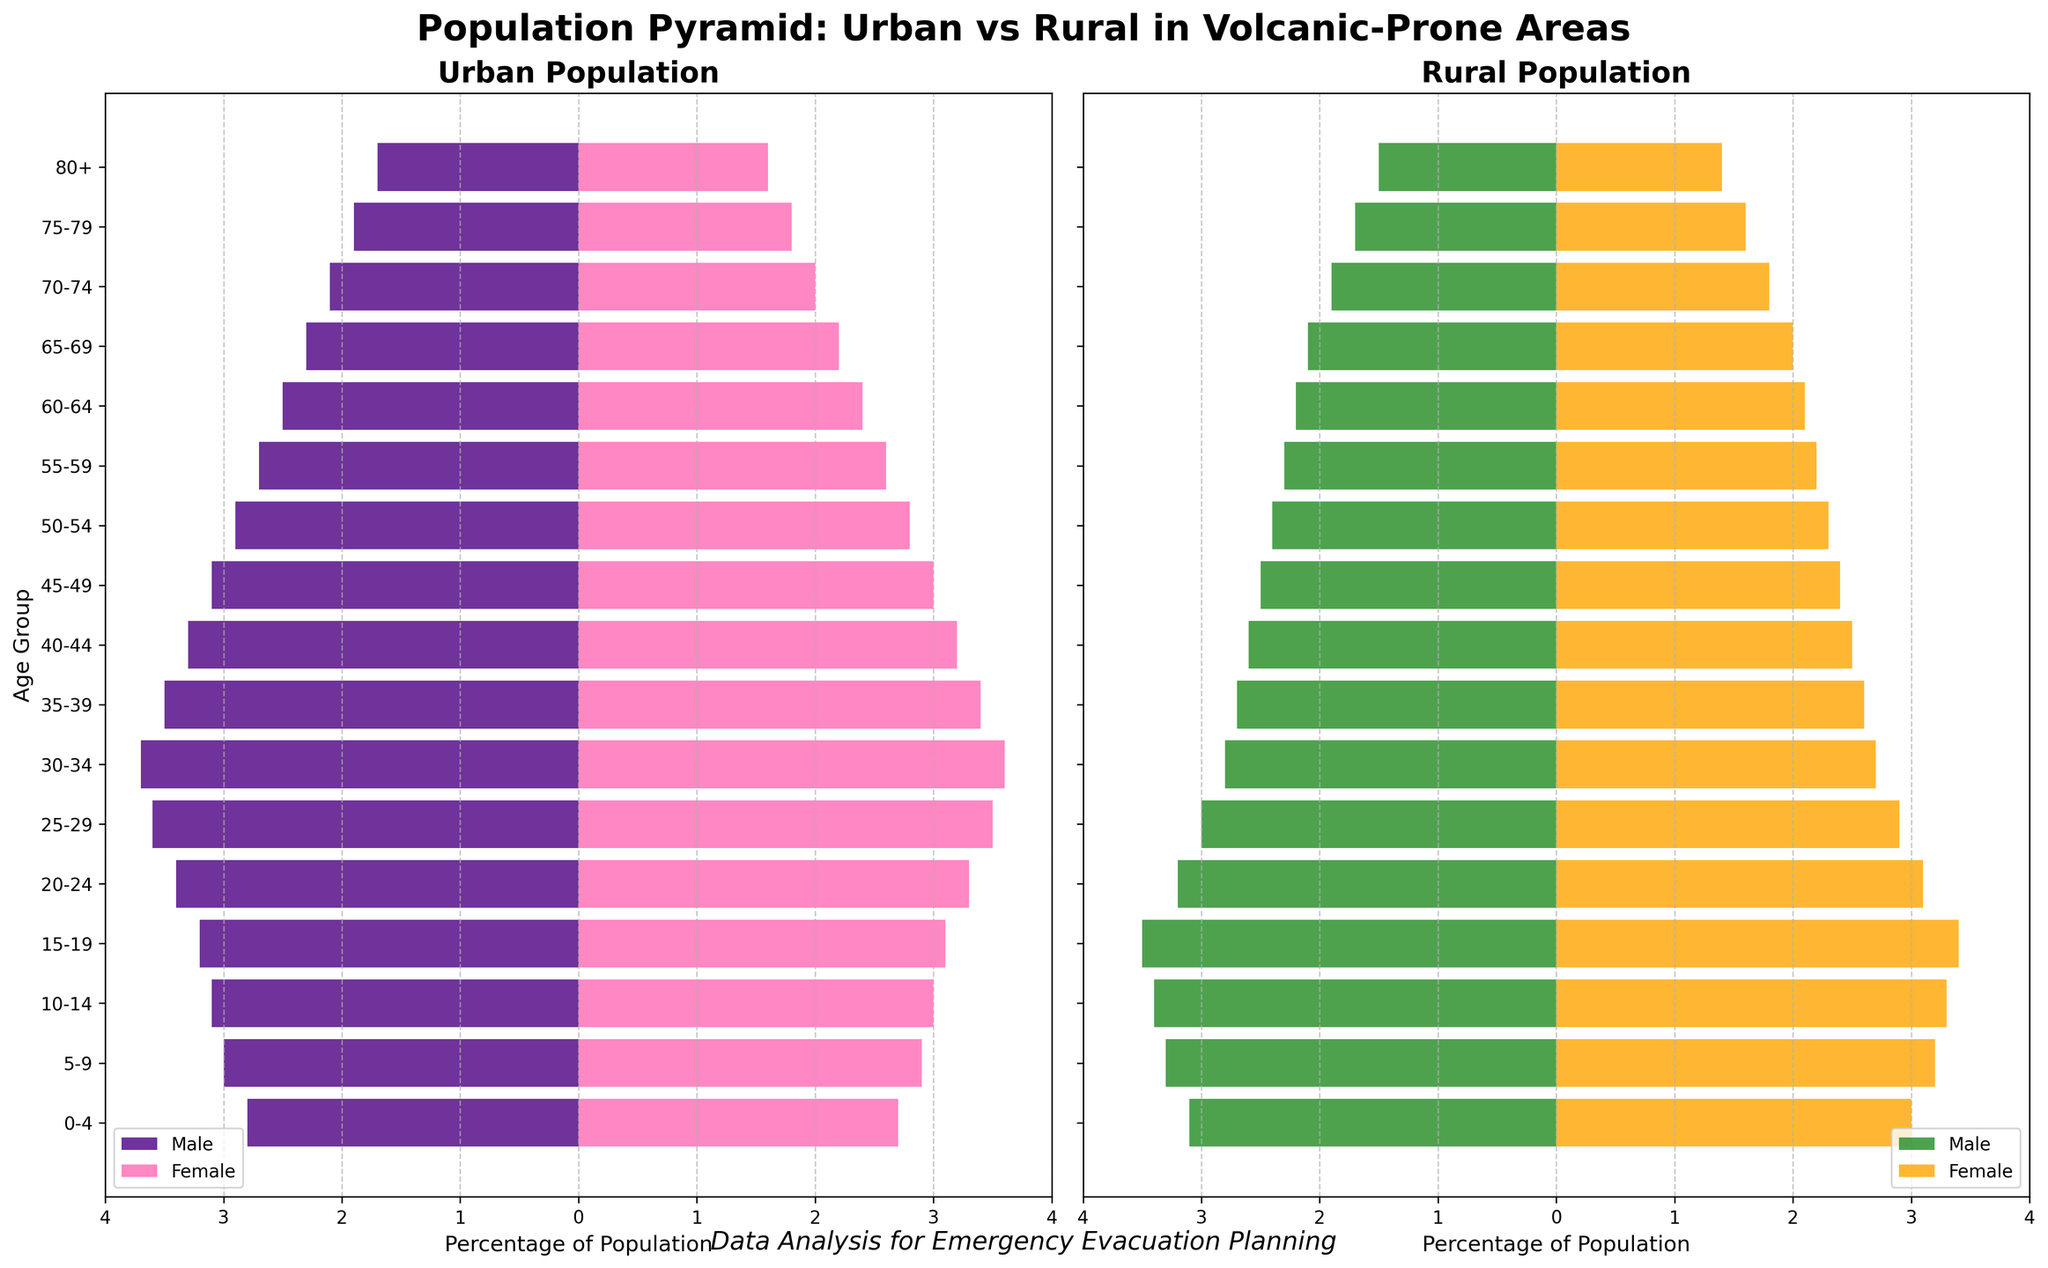What is the title of the figure? The title of the figure is presented at the top and reads 'Population Pyramid: Urban vs Rural in Volcanic-Prone Areas'.
Answer: Population Pyramid: Urban vs Rural in Volcanic-Prone Areas What age group has the highest percentage in the urban male population? Look at the urban male side (left side of the urban plot) and identify the age group with the furthest bar extension to the left. The greatest extension is for the 30-34 age group.
Answer: 30-34 Comparing urban and rural female populations aged 15-19, which group has a higher percentage? Compare the length of the bars for the 15-19 age group in the urban female (pink bar) and rural female (orange bar) populations. The urban female population has a percentage of 3.1%, while the rural female population has 3.4%.
Answer: Rural Female Which age group has the smallest difference between urban and rural populations for females? Calculate the differences for each age group. One way to interpret this is by visual inspection of the bars where the urban and rural female population bars are closest in length. For the smallest visual difference, it is for the 20-24 age group (urban: 3.3%, rural: 3.1%).
Answer: 20-24 What is the trend for the percentage of urban males aged 75-79 compared to 80+? Compare the lengths of the bars for these age groups on the urban male side. The percentage decreases from 1.9% for 75-79 to 1.7% for 80+.
Answer: Decreasing Which gender shows a higher percentage of 65-69 year-olds in rural areas? Compare the lengths of the bars for both male and female in the 65-69 age group within the rural population plot. Rural males have 2.1%, and rural females have 2.0%.
Answer: Male For the age group 55-59, what is the combined percentage of males and females in the urban population? Sum the percentages for urban males (2.7%) and urban females (2.6%) in the 55-59 age group. 2.7% + 2.6% = 5.3%.
Answer: 5.3% How does the gender distribution in the rural population for the age group 25-29 compare? Look at the length of the bars for rural males and females in the 25-29 age group. Rural males have a percentage of 3.0% while rural females have a percentage of 2.9%.
Answer: Males have a slightly higher percentage Which population has the higher percentage of people in the 50-54 age group, urban or rural? Compare the sum of male and female percentages for urban and rural populations in the 50-54 age group. Urban population: 2.9% (male) + 2.8% (female) = 5.7%. Rural population: 2.4% (male) + 2.3% (female) = 4.7%.
Answer: Urban 